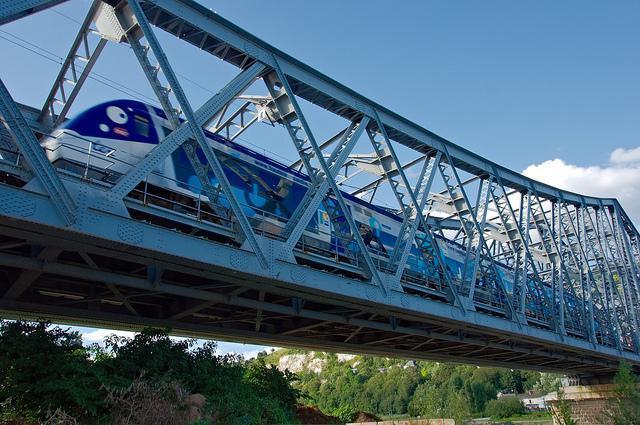How many trains are on the bridge?
Give a very brief answer. 1. 